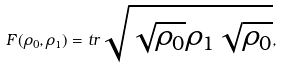<formula> <loc_0><loc_0><loc_500><loc_500>F ( \rho _ { 0 } , \rho _ { 1 } ) = t r \sqrt { \sqrt { \rho _ { 0 } } \rho _ { 1 } \sqrt { \rho _ { 0 } } } ,</formula> 